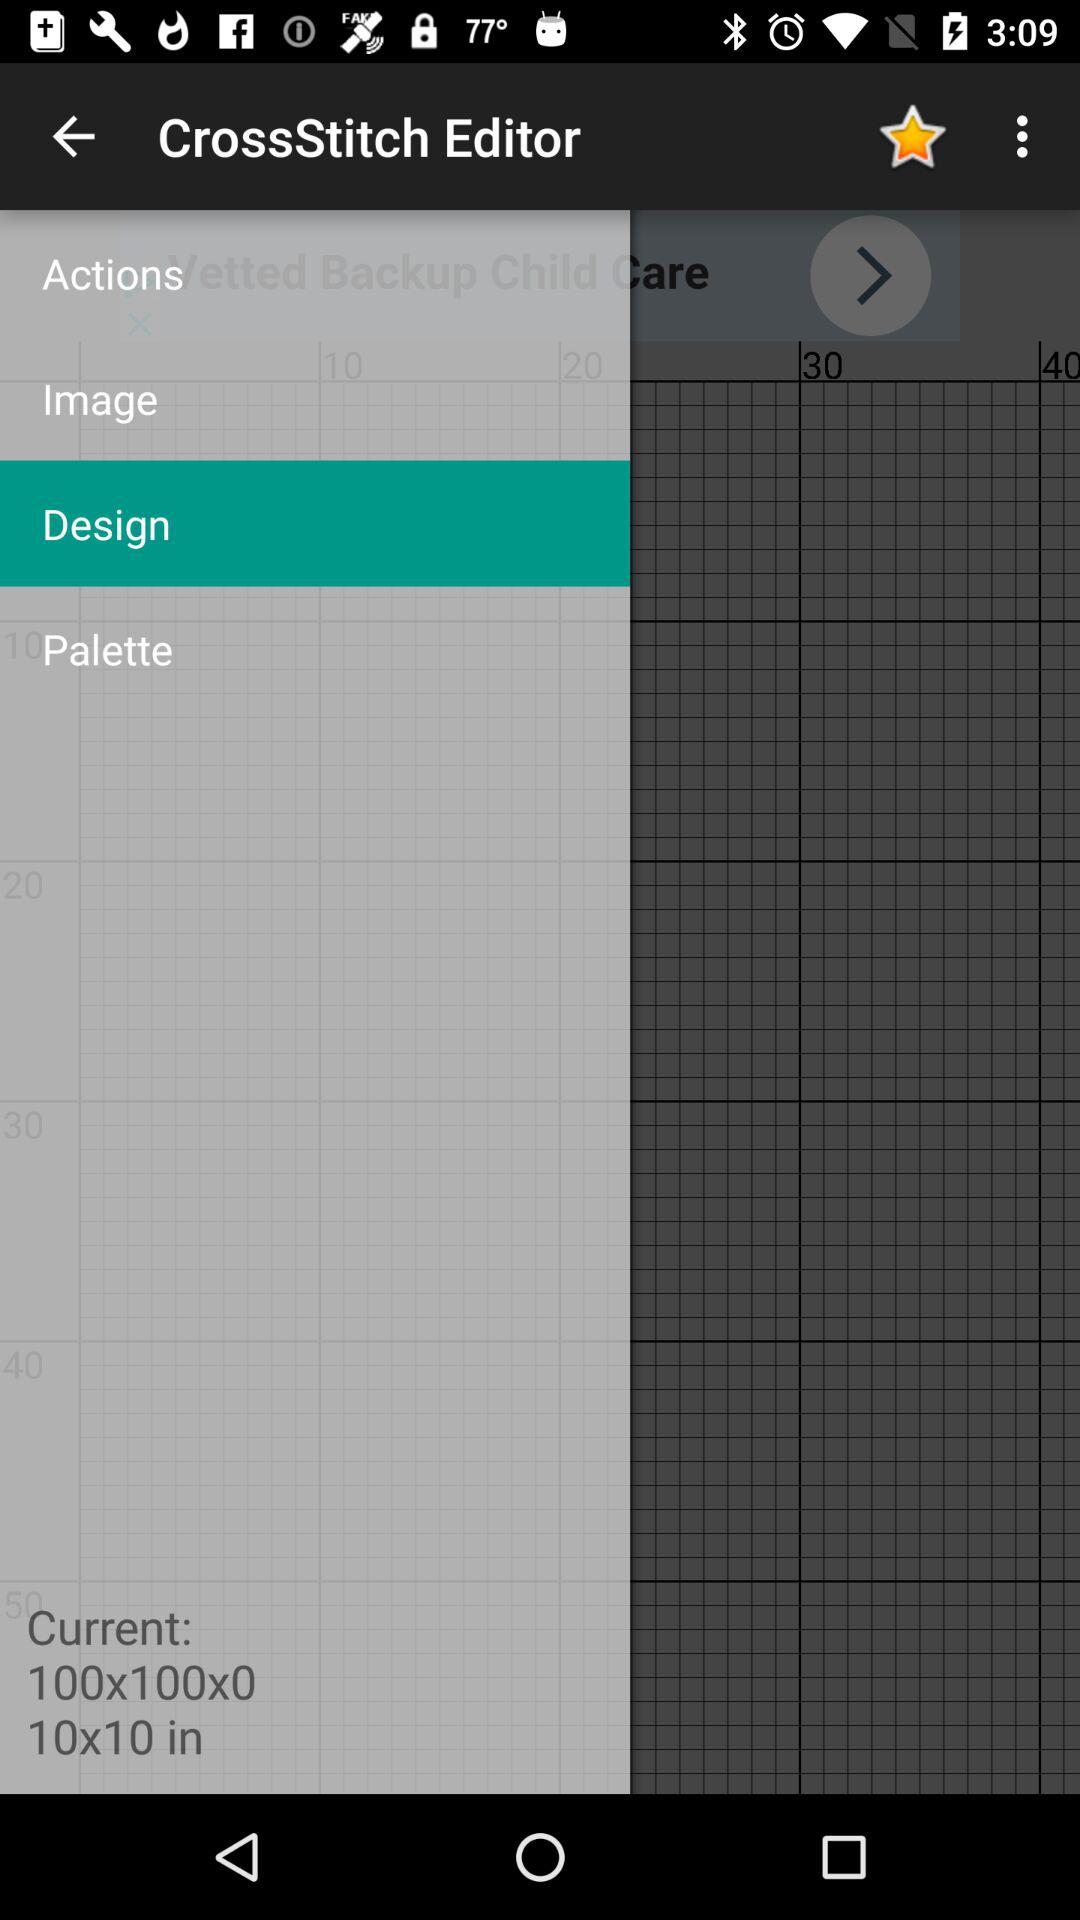What is the application name? The application name is "CrossStitch Editor". 